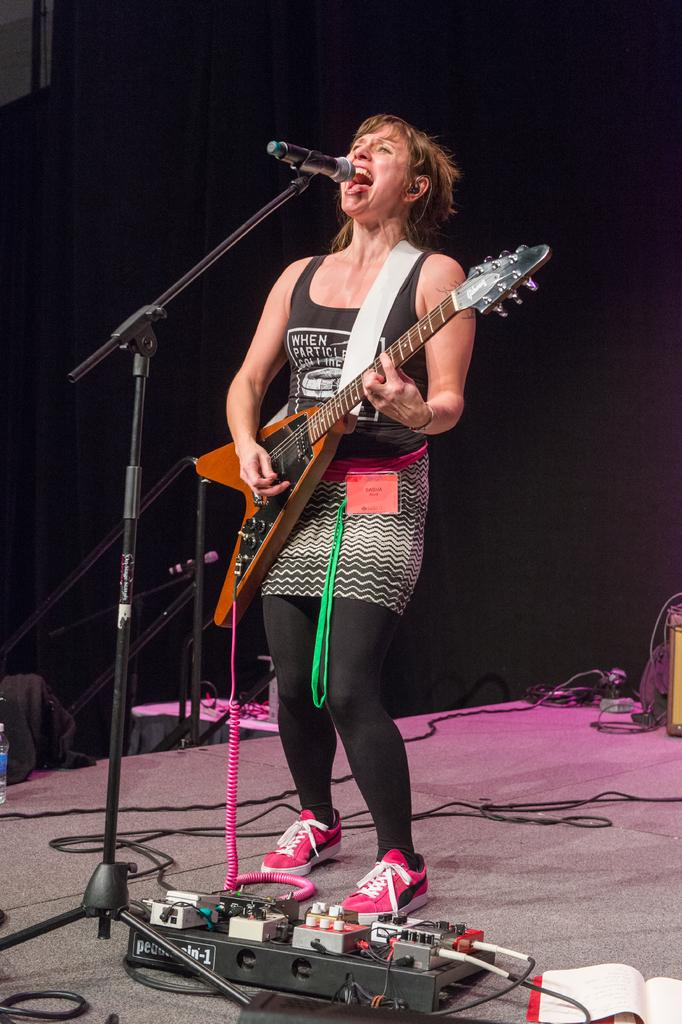What is the woman in the image doing? The woman is playing the guitar and singing with a microphone. How is the woman using the microphone? The microphone is in front of the woman, and she is singing into it. What is located at the bottom of the image? There is an amplifier at the bottom of the image. What type of polish is the woman applying to her nails in the image? There is no indication in the image that the woman is applying any polish to her nails. How many fans are visible in the image? There are no fans present in the image. 